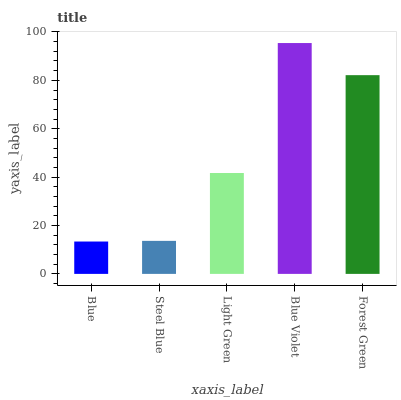Is Blue the minimum?
Answer yes or no. Yes. Is Blue Violet the maximum?
Answer yes or no. Yes. Is Steel Blue the minimum?
Answer yes or no. No. Is Steel Blue the maximum?
Answer yes or no. No. Is Steel Blue greater than Blue?
Answer yes or no. Yes. Is Blue less than Steel Blue?
Answer yes or no. Yes. Is Blue greater than Steel Blue?
Answer yes or no. No. Is Steel Blue less than Blue?
Answer yes or no. No. Is Light Green the high median?
Answer yes or no. Yes. Is Light Green the low median?
Answer yes or no. Yes. Is Steel Blue the high median?
Answer yes or no. No. Is Blue Violet the low median?
Answer yes or no. No. 